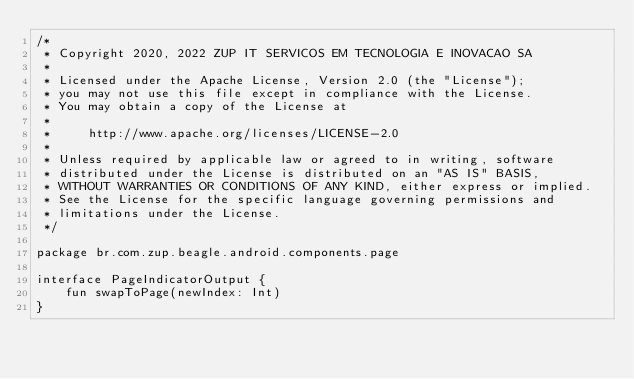Convert code to text. <code><loc_0><loc_0><loc_500><loc_500><_Kotlin_>/*
 * Copyright 2020, 2022 ZUP IT SERVICOS EM TECNOLOGIA E INOVACAO SA
 *
 * Licensed under the Apache License, Version 2.0 (the "License");
 * you may not use this file except in compliance with the License.
 * You may obtain a copy of the License at
 *
 *     http://www.apache.org/licenses/LICENSE-2.0
 *
 * Unless required by applicable law or agreed to in writing, software
 * distributed under the License is distributed on an "AS IS" BASIS,
 * WITHOUT WARRANTIES OR CONDITIONS OF ANY KIND, either express or implied.
 * See the License for the specific language governing permissions and
 * limitations under the License.
 */

package br.com.zup.beagle.android.components.page

interface PageIndicatorOutput {
    fun swapToPage(newIndex: Int)
}</code> 